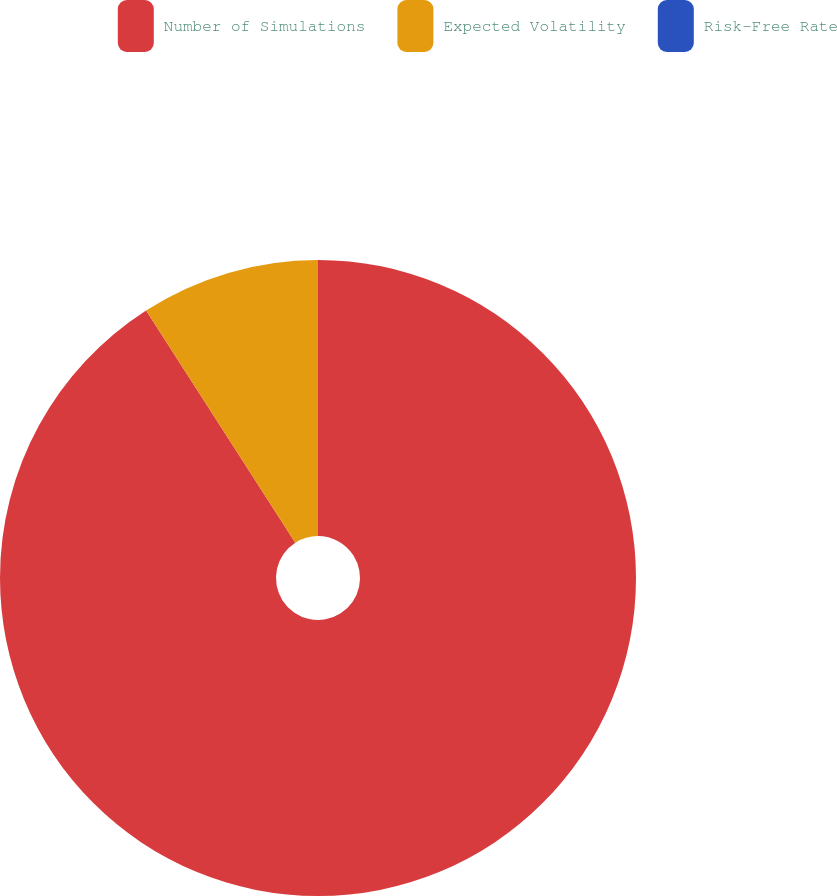Convert chart to OTSL. <chart><loc_0><loc_0><loc_500><loc_500><pie_chart><fcel>Number of Simulations<fcel>Expected Volatility<fcel>Risk-Free Rate<nl><fcel>90.91%<fcel>9.09%<fcel>0.0%<nl></chart> 